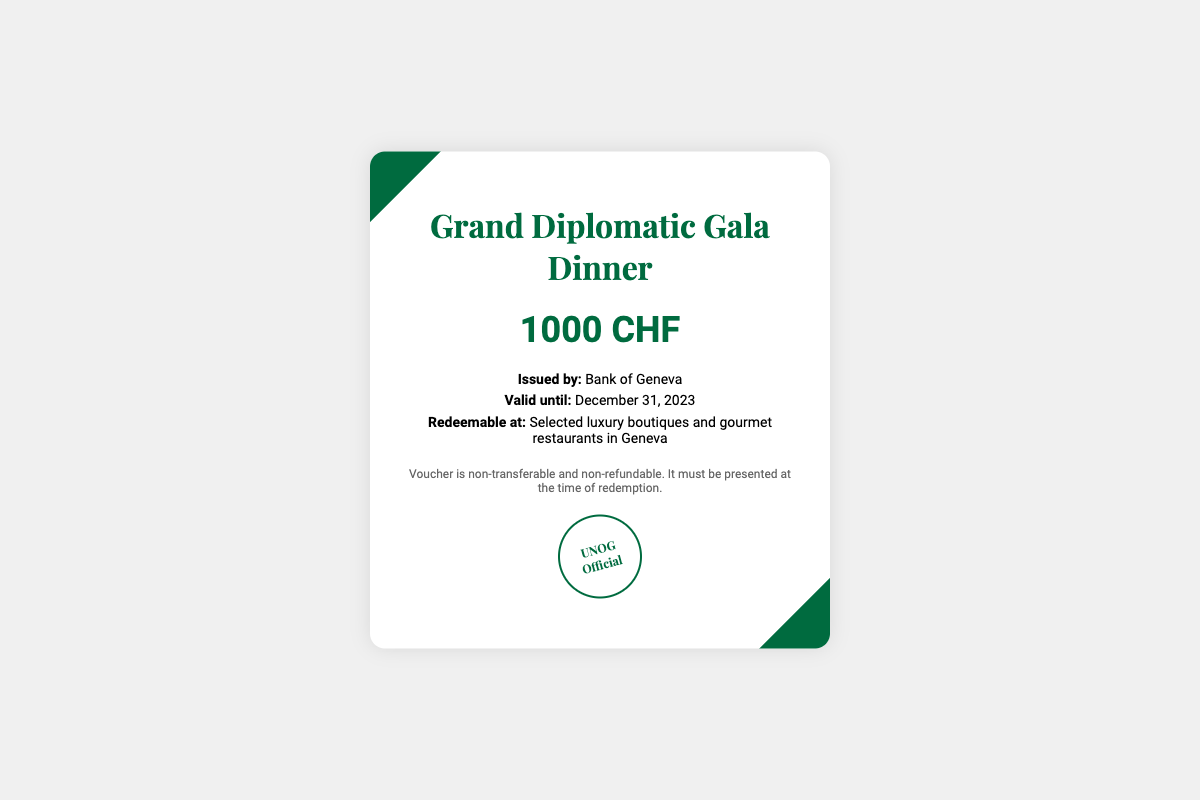What is the title of the event? The title of the event is prominently stated in the heading of the document as "Grand Diplomatic Gala Dinner."
Answer: Grand Diplomatic Gala Dinner Who issued the voucher? The issuer of the voucher is mentioned in the details section, indicating the Bank responsible for it.
Answer: Bank of Geneva What is the value of the voucher? The value of the voucher is specified in large font text, indicating the monetary amount it represents.
Answer: 1000 CHF When does the voucher expire? The valid until date is clearly stated in the details section, indicating the last date it can be used for redemption.
Answer: December 31, 2023 Where can the voucher be redeemed? The redeemable location is specified in the details section, mentioning the types of establishments where it can be used.
Answer: Selected luxury boutiques and gourmet restaurants in Geneva Is the voucher transferable? The conditions outline whether the voucher can be transferred or not, providing clarity on the terms of use.
Answer: No What type of document is this? The overall structure and purpose of the document indicate that it is a type of promotional or gift item, specifically designed for an event invitation in the diplomatic context.
Answer: Gift voucher What is the significance of the seal? The presence of the seal is indicative of its authenticity and which organization endorses it, as described in the seal section.
Answer: UNOG Official 